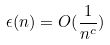Convert formula to latex. <formula><loc_0><loc_0><loc_500><loc_500>\epsilon ( n ) = O ( \frac { 1 } { n ^ { c } } )</formula> 